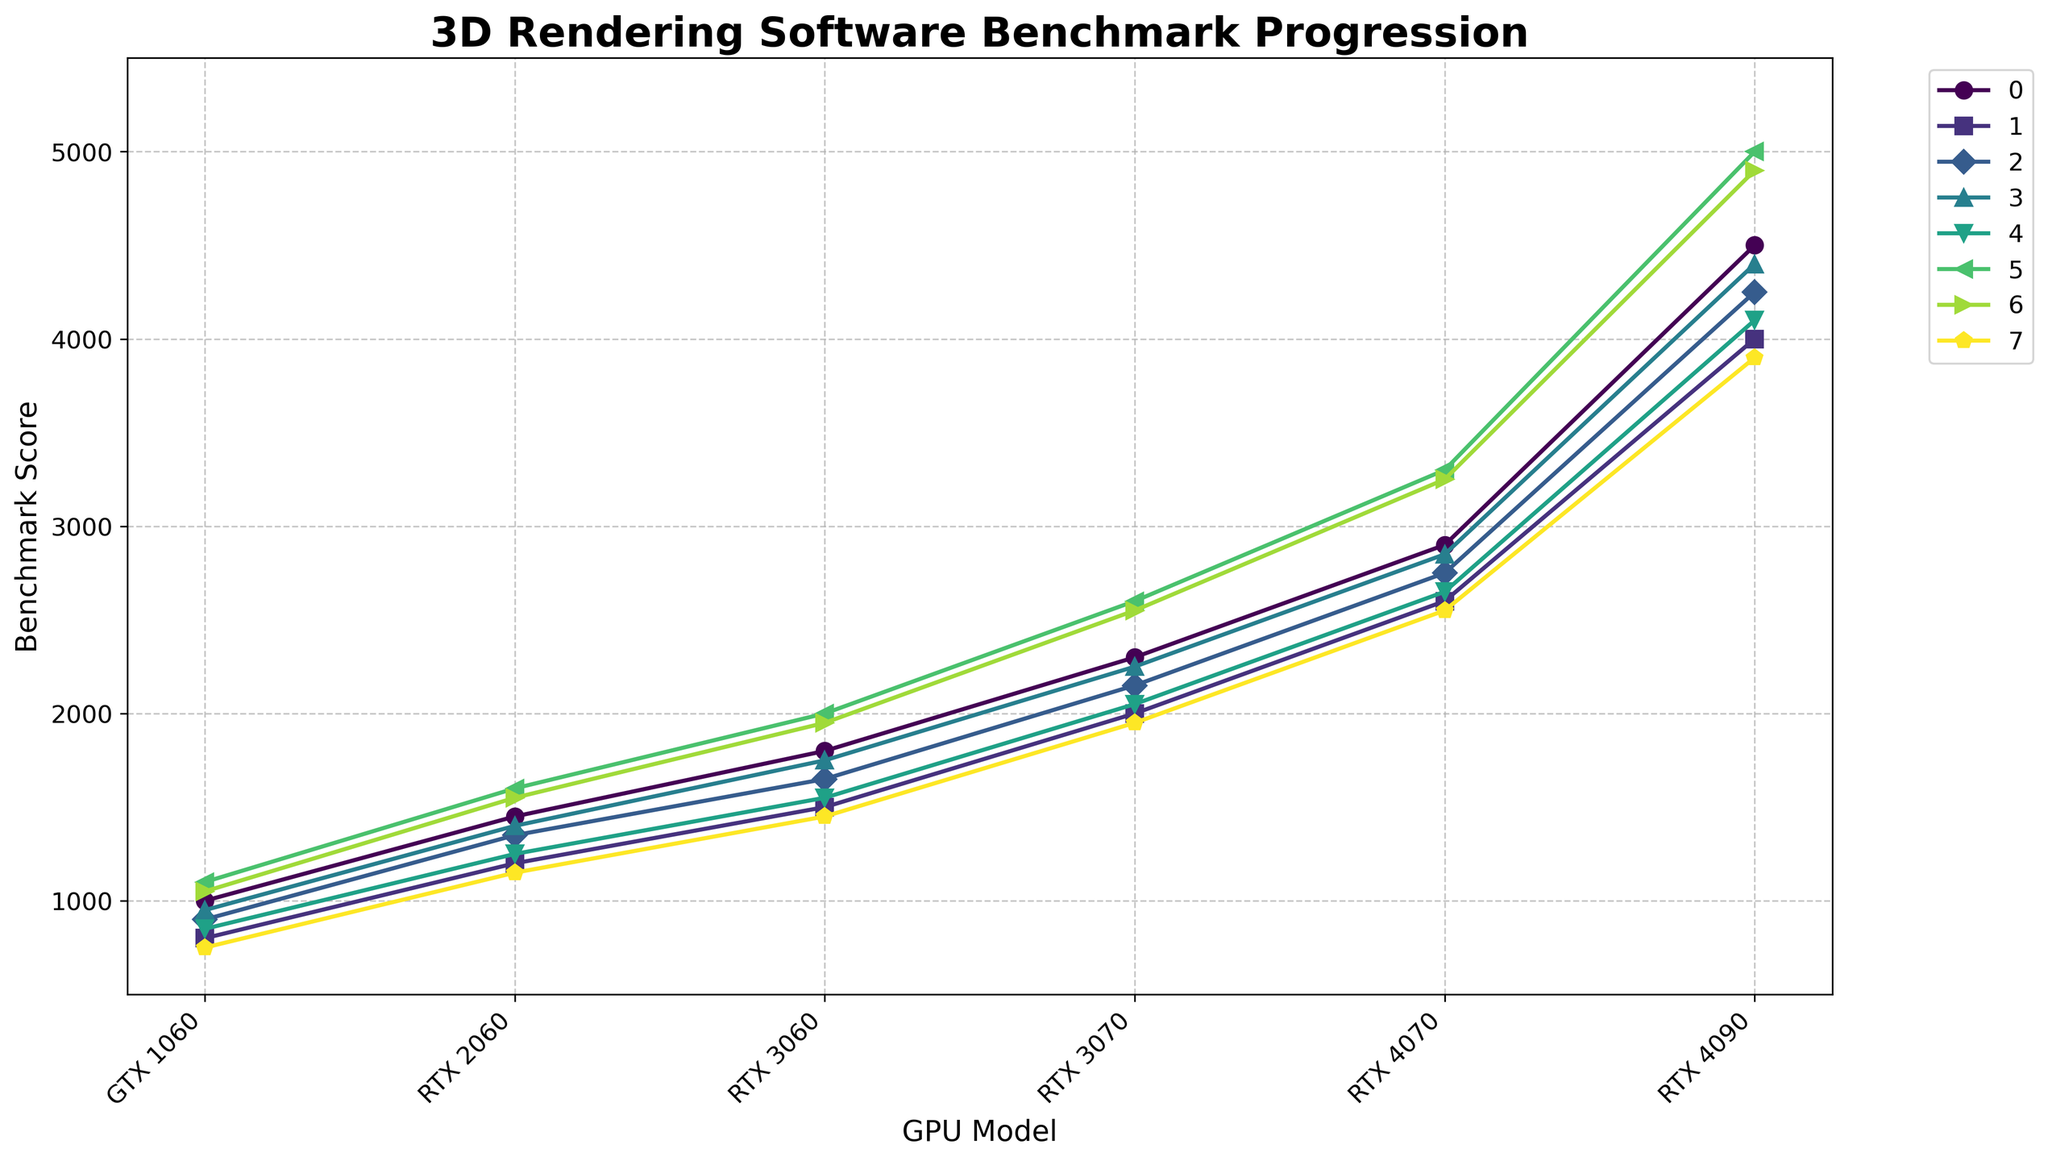Which software shows the highest benchmark score progression for the RTX 4090? To find this, look for the highest value in the RTX 4090 column of the figure. Compare the scores for all software listed.
Answer: Octane Render Which software had the smallest improvement in benchmark score from GTX 1060 to RTX 2060? Calculate the improvement for each software by subtracting the GTX 1060 score from the RTX 2060 score. Compare these differences to find the smallest one.
Answer: Arnold What's the average benchmark score for Redshift across all GPU models? Add up Redshift's benchmark scores for each GPU model (1050 + 1550 + 1950 + 2550 + 3250 + 4900) and divide by the number of GPU models (6).
Answer: 2541.67 Which two software show the closest benchmark scores for the GPU model RTX 3070? Compare the benchmark scores for the RTX 3070 column and identify the two software with the smallest difference between their scores.
Answer: Cinema 4D and Redshift By how much does Blender's benchmark score increase when upgrading from RTX 3060 to RTX 4090? Subtract Blender's RTX 3060 score from its RTX 4090 score (4500 - 1800).
Answer: 2700 Which GPU model shows the highest overall variance in benchmark scores among all software? Calculate the variance for each GPU model by determining the difference between the highest and lowest scores within that model. Identify the model with the highest variance.
Answer: RTX 4090 What's the median benchmark score for Maya across all GPU models? Order Maya's benchmark scores (900, 1350, 1650, 2150, 2750, 4250) and find the median by averaging the two middle values ((1650 + 2150) / 2).
Answer: 1900 Which software shows the most consistent improvement in benchmark scores across the GPU models? Identify the software with the smallest differences between successive GPU scores, indicating consistent improvement.
Answer: Blender Between 3ds Max and V-Ray, which one shows a larger increase in benchmark score from RTX 2060 to RTX 4070? Calculate the increase for each software by subtracting the RTX 2060 score from the RTX 4070 score and compare them ((2600 - 1200) for 3ds Max, (2650 - 1250) for V-Ray).
Answer: V-Ray Which software shows the least improvement in benchmark score when upgrading to RTX 3070? Compare the improvement for each software by subtracting the RTX 3060 score from the RTX 3070 score, then identify the smallest one.
Answer: Blender 